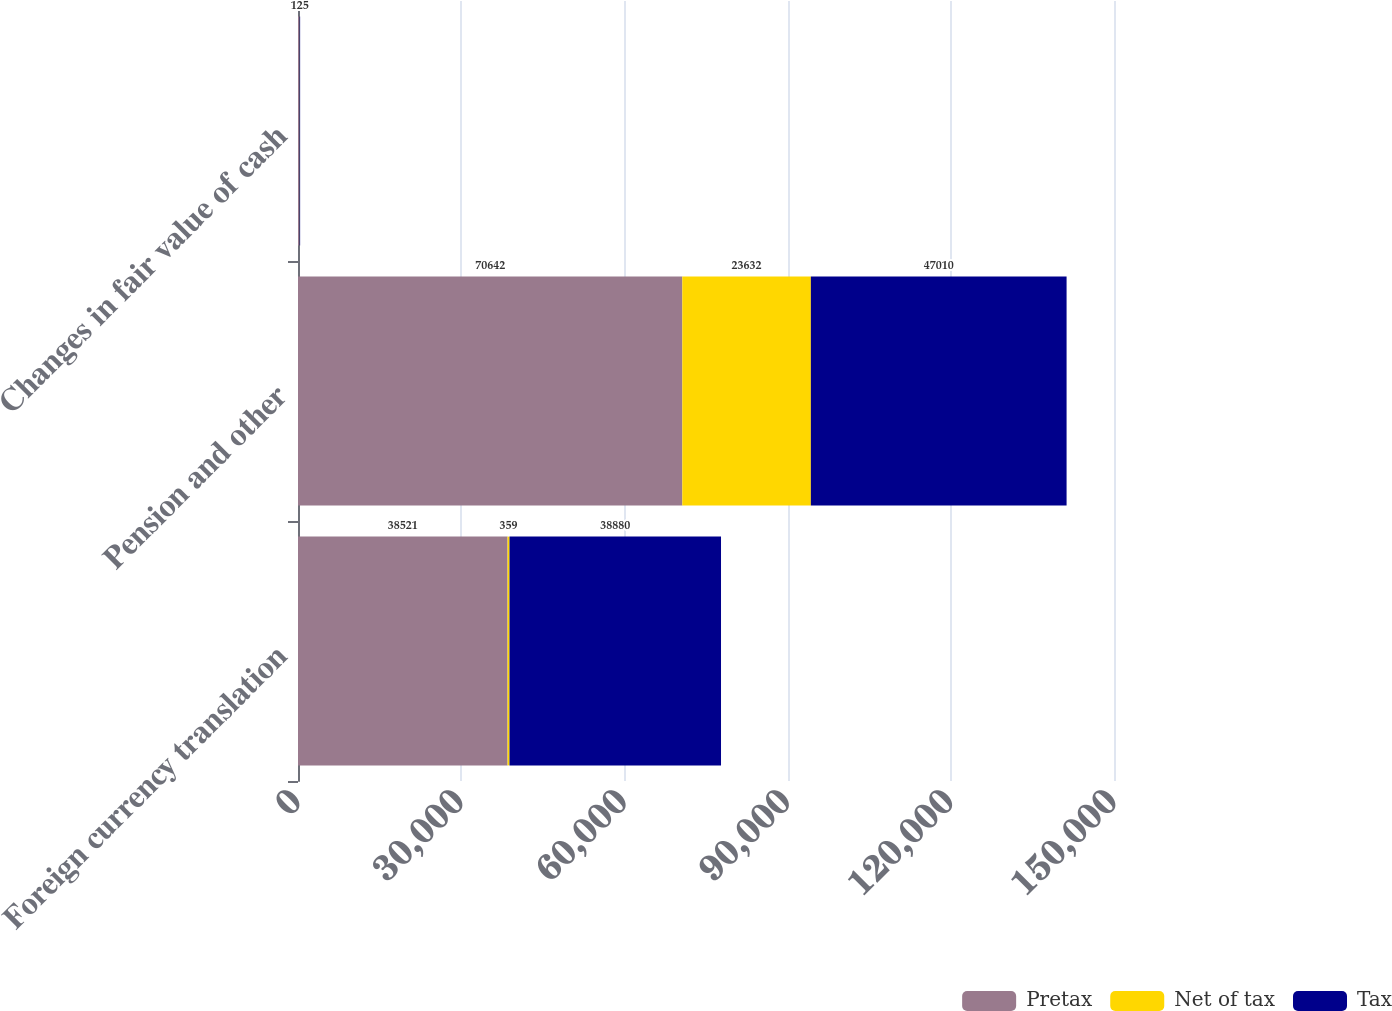Convert chart to OTSL. <chart><loc_0><loc_0><loc_500><loc_500><stacked_bar_chart><ecel><fcel>Foreign currency translation<fcel>Pension and other<fcel>Changes in fair value of cash<nl><fcel>Pretax<fcel>38521<fcel>70642<fcel>195<nl><fcel>Net of tax<fcel>359<fcel>23632<fcel>70<nl><fcel>Tax<fcel>38880<fcel>47010<fcel>125<nl></chart> 